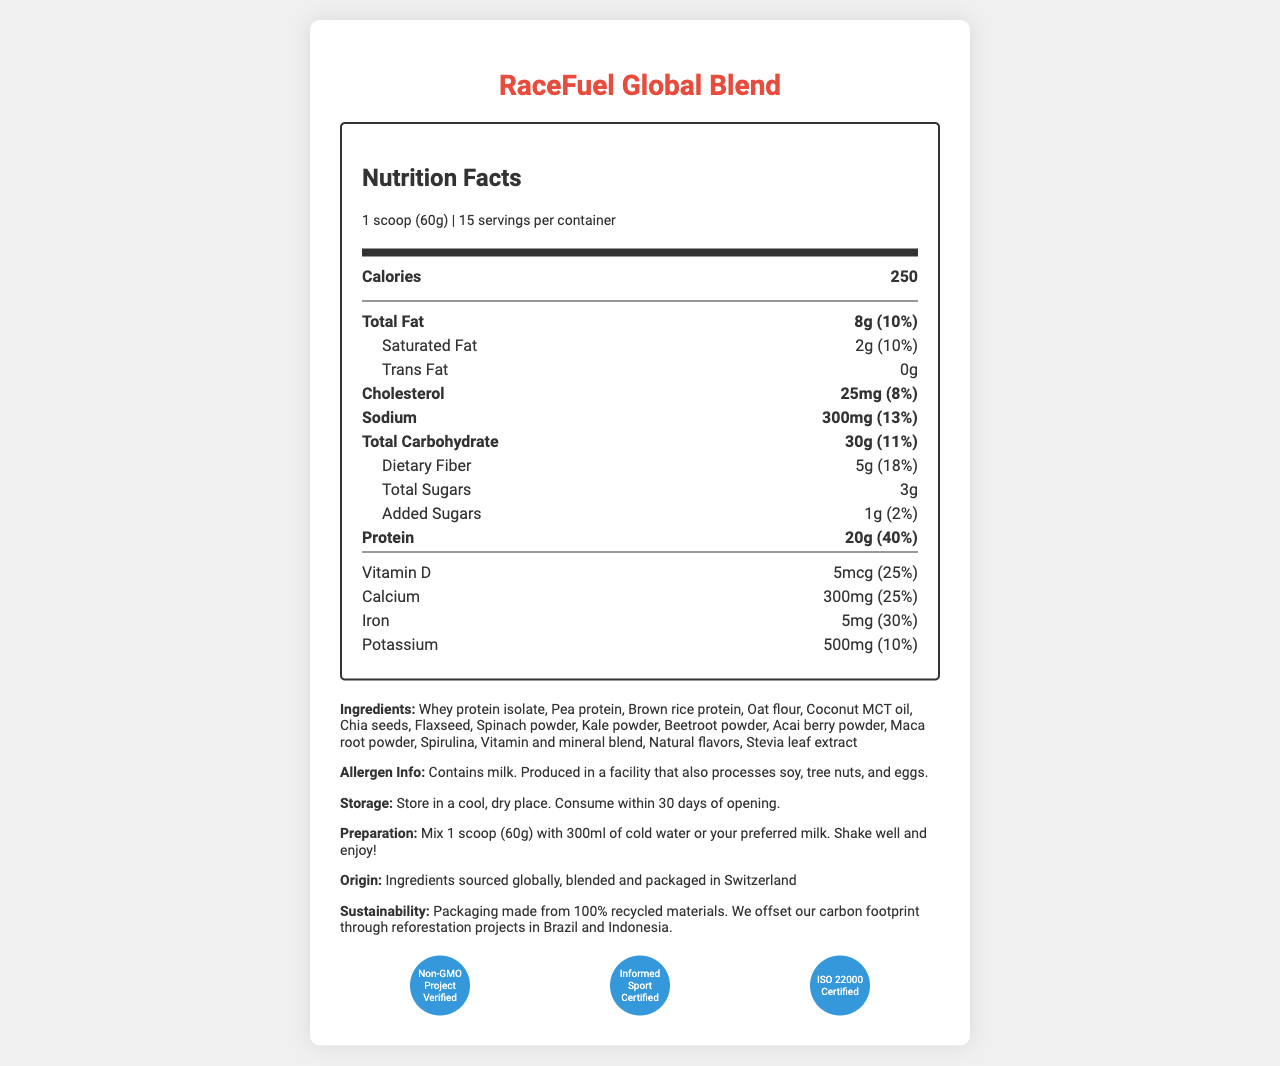what is the serving size of the RaceFuel Global Blend? The serving size is explicitly listed under the "Nutrition Facts" header as "1 scoop (60g)".
Answer: 1 scoop (60g) how many servings are there per container? The document specifies "15 servings per container" under the "Nutrition Facts" section.
Answer: 15 how many calories are in one serving? The "Nutrition Facts" section lists "Calories" with a value of 250 for one serving.
Answer: 250 what is the percentage of daily value for protein in one serving? The document states that one serving of the product provides 40% of the daily value for protein.
Answer: 40% list three key ingredients in the RaceFuel Global Blend The document states several ingredients, with "Whey protein isolate, Pea protein, Brown rice protein" being some of the first mentioned.
Answer: Whey protein isolate, Pea protein, Brown rice protein which vitamin has the highest daily value percentage? A. Vitamin D B. Vitamin A C. Vitamin E The document indicates that Vitamin A, C, E, K, and several B vitamins all provide 50% of the daily value, but Vitamin A is listed first among those.
Answer: B how much dietary fiber is in one serving? A. 3g B. 5g C. 8g D. 10g The "Nutrition Facts" section lists "Dietary Fiber" with a value of 5g per serving.
Answer: B is the product Non-GMO Project Verified? Under the "certifications" section, it states that the product is "Non-GMO Project Verified".
Answer: Yes describe the main idea of the document The document offers comprehensive information about a meal replacement shake tailored for racing teams, focusing on nutritional content, ingredients, and certifications.
Answer: The document provides a detailed nutrition label for RaceFuel Global Blend, a globally sourced, nutrient-dense meal replacement shake tailored for traveling racing teams. It includes nutritional information, serving size, ingredients, allergen information, storage and preparation instructions, origin, and certifications. where are the ingredients sourced and where is the product packaged? The "product origin" section states that the ingredients are globally sourced and the product is blended and packaged in Switzerland.
Answer: Ingredients sourced globally, blended and packaged in Switzerland Does the document indicate whether this product contains any allergens? The allergen information section indicates that the product contains milk and is produced in a facility that processes soy, tree nuts, and eggs.
Answer: Yes Can you determine the exact cost per serving of the product from this document? The document does not provide any pricing information, so the cost per serving cannot be determined.
Answer: Cannot be determined what is the daily value percentage for sodium? The "Nutrition Facts" section specifies that the sodium content is 300mg per serving, which is 13% of the daily value.
Answer: 13% how is the product environmentally sustainable? The sustainability information indicates the eco-friendly packaging and carbon offset initiatives through reforestation.
Answer: Packaging made from 100% recycled materials; Carbon footprint offset through reforestation projects in Brazil and Indonesia is there any trans fat in one serving of the product? The "Nutrition Facts" section specifies "0g" for Trans Fat.
Answer: No which certifications does the product have? A. Non-GMO Project Verified B. Informed Sport Certified C. ISO 22000 Certified D. All of the above The document lists all these certifications under the "certifications" section.
Answer: D 